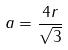<formula> <loc_0><loc_0><loc_500><loc_500>a = \frac { 4 r } { \sqrt { 3 } }</formula> 